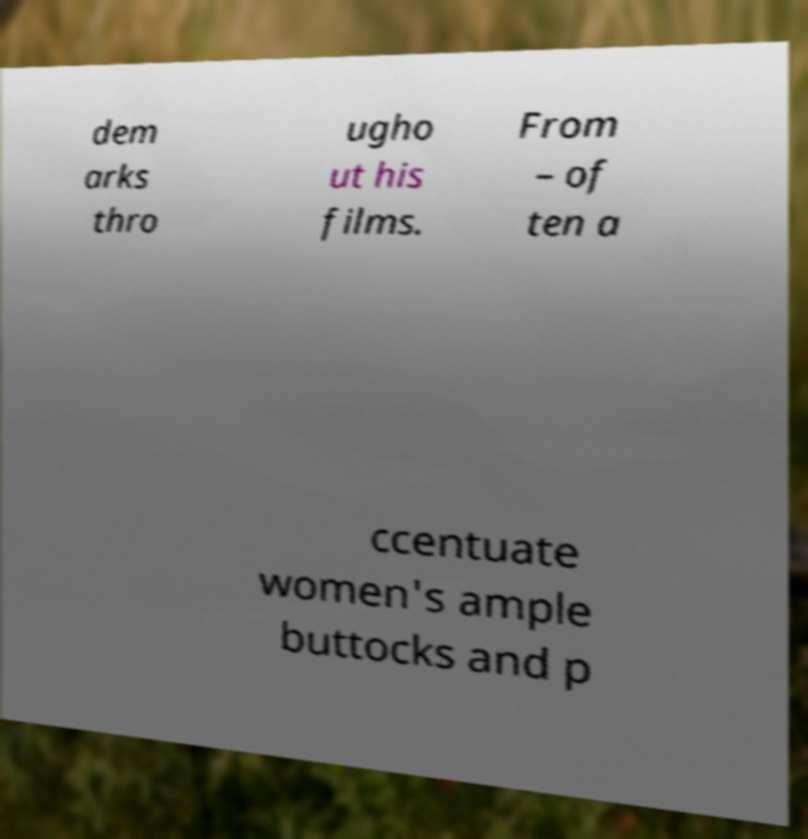Can you accurately transcribe the text from the provided image for me? dem arks thro ugho ut his films. From – of ten a ccentuate women's ample buttocks and p 